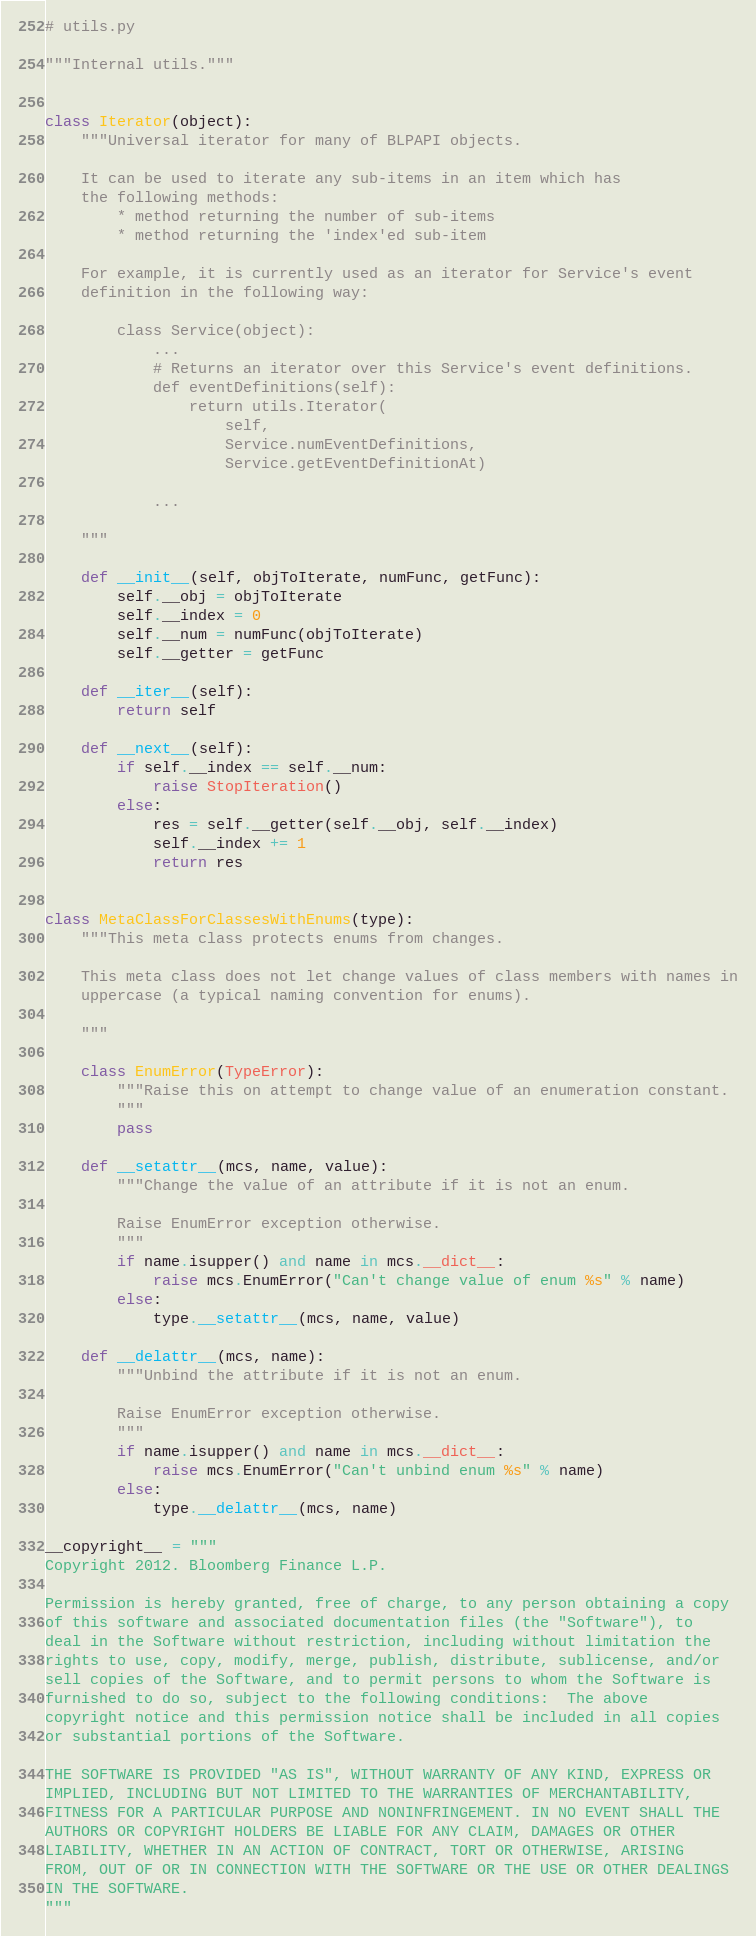<code> <loc_0><loc_0><loc_500><loc_500><_Python_># utils.py

"""Internal utils."""


class Iterator(object):
    """Universal iterator for many of BLPAPI objects.

    It can be used to iterate any sub-items in an item which has
    the following methods:
        * method returning the number of sub-items
        * method returning the 'index'ed sub-item

    For example, it is currently used as an iterator for Service's event
    definition in the following way:

        class Service(object):
            ...
            # Returns an iterator over this Service's event definitions.
            def eventDefinitions(self):
                return utils.Iterator(
                    self,
                    Service.numEventDefinitions,
                    Service.getEventDefinitionAt)

            ...

    """

    def __init__(self, objToIterate, numFunc, getFunc):
        self.__obj = objToIterate
        self.__index = 0
        self.__num = numFunc(objToIterate)
        self.__getter = getFunc

    def __iter__(self):
        return self

    def __next__(self):
        if self.__index == self.__num:
            raise StopIteration()
        else:
            res = self.__getter(self.__obj, self.__index)
            self.__index += 1
            return res


class MetaClassForClassesWithEnums(type):
    """This meta class protects enums from changes.

    This meta class does not let change values of class members with names in
    uppercase (a typical naming convention for enums).

    """

    class EnumError(TypeError):
        """Raise this on attempt to change value of an enumeration constant.
        """
        pass

    def __setattr__(mcs, name, value):
        """Change the value of an attribute if it is not an enum.

        Raise EnumError exception otherwise.
        """
        if name.isupper() and name in mcs.__dict__:
            raise mcs.EnumError("Can't change value of enum %s" % name)
        else:
            type.__setattr__(mcs, name, value)

    def __delattr__(mcs, name):
        """Unbind the attribute if it is not an enum.

        Raise EnumError exception otherwise.
        """
        if name.isupper() and name in mcs.__dict__:
            raise mcs.EnumError("Can't unbind enum %s" % name)
        else:
            type.__delattr__(mcs, name)

__copyright__ = """
Copyright 2012. Bloomberg Finance L.P.

Permission is hereby granted, free of charge, to any person obtaining a copy
of this software and associated documentation files (the "Software"), to
deal in the Software without restriction, including without limitation the
rights to use, copy, modify, merge, publish, distribute, sublicense, and/or
sell copies of the Software, and to permit persons to whom the Software is
furnished to do so, subject to the following conditions:  The above
copyright notice and this permission notice shall be included in all copies
or substantial portions of the Software.

THE SOFTWARE IS PROVIDED "AS IS", WITHOUT WARRANTY OF ANY KIND, EXPRESS OR
IMPLIED, INCLUDING BUT NOT LIMITED TO THE WARRANTIES OF MERCHANTABILITY,
FITNESS FOR A PARTICULAR PURPOSE AND NONINFRINGEMENT. IN NO EVENT SHALL THE
AUTHORS OR COPYRIGHT HOLDERS BE LIABLE FOR ANY CLAIM, DAMAGES OR OTHER
LIABILITY, WHETHER IN AN ACTION OF CONTRACT, TORT OR OTHERWISE, ARISING
FROM, OUT OF OR IN CONNECTION WITH THE SOFTWARE OR THE USE OR OTHER DEALINGS
IN THE SOFTWARE.
"""
</code> 